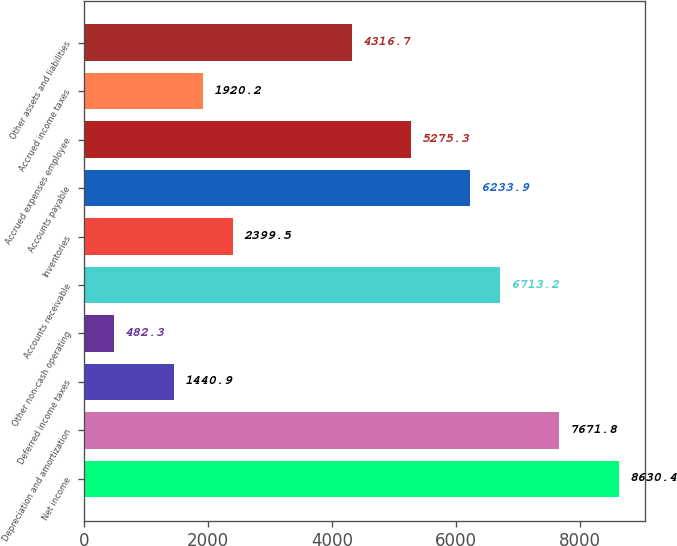<chart> <loc_0><loc_0><loc_500><loc_500><bar_chart><fcel>Net income<fcel>Depreciation and amortization<fcel>Deferred income taxes<fcel>Other non-cash operating<fcel>Accounts receivable<fcel>Inventories<fcel>Accounts payable<fcel>Accrued expenses employee<fcel>Accrued income taxes<fcel>Other assets and liabilities<nl><fcel>8630.4<fcel>7671.8<fcel>1440.9<fcel>482.3<fcel>6713.2<fcel>2399.5<fcel>6233.9<fcel>5275.3<fcel>1920.2<fcel>4316.7<nl></chart> 